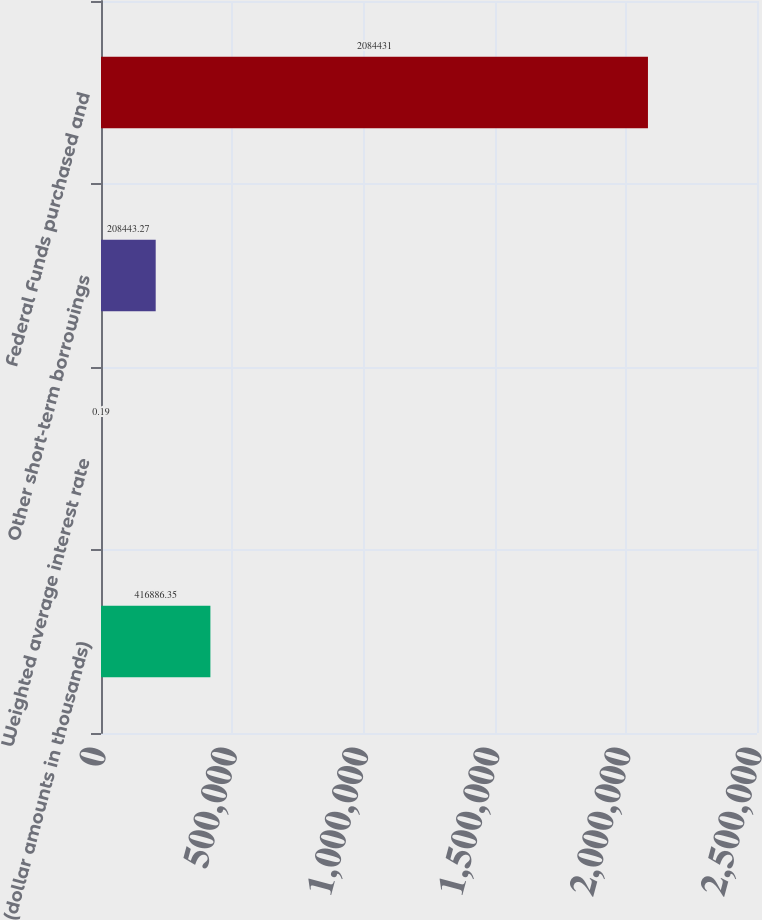Convert chart to OTSL. <chart><loc_0><loc_0><loc_500><loc_500><bar_chart><fcel>(dollar amounts in thousands)<fcel>Weighted average interest rate<fcel>Other short-term borrowings<fcel>Federal Funds purchased and<nl><fcel>416886<fcel>0.19<fcel>208443<fcel>2.08443e+06<nl></chart> 